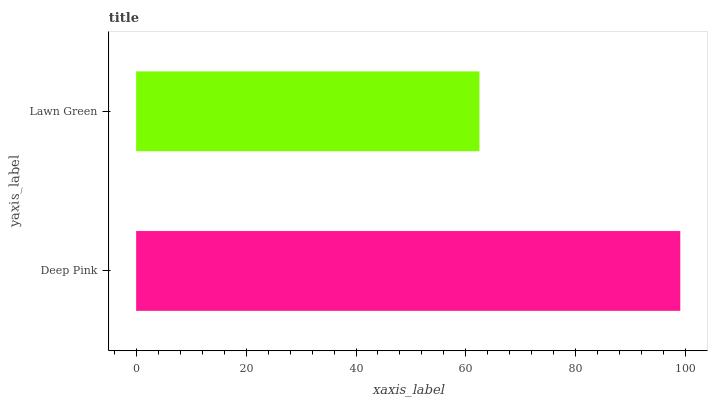Is Lawn Green the minimum?
Answer yes or no. Yes. Is Deep Pink the maximum?
Answer yes or no. Yes. Is Lawn Green the maximum?
Answer yes or no. No. Is Deep Pink greater than Lawn Green?
Answer yes or no. Yes. Is Lawn Green less than Deep Pink?
Answer yes or no. Yes. Is Lawn Green greater than Deep Pink?
Answer yes or no. No. Is Deep Pink less than Lawn Green?
Answer yes or no. No. Is Deep Pink the high median?
Answer yes or no. Yes. Is Lawn Green the low median?
Answer yes or no. Yes. Is Lawn Green the high median?
Answer yes or no. No. Is Deep Pink the low median?
Answer yes or no. No. 